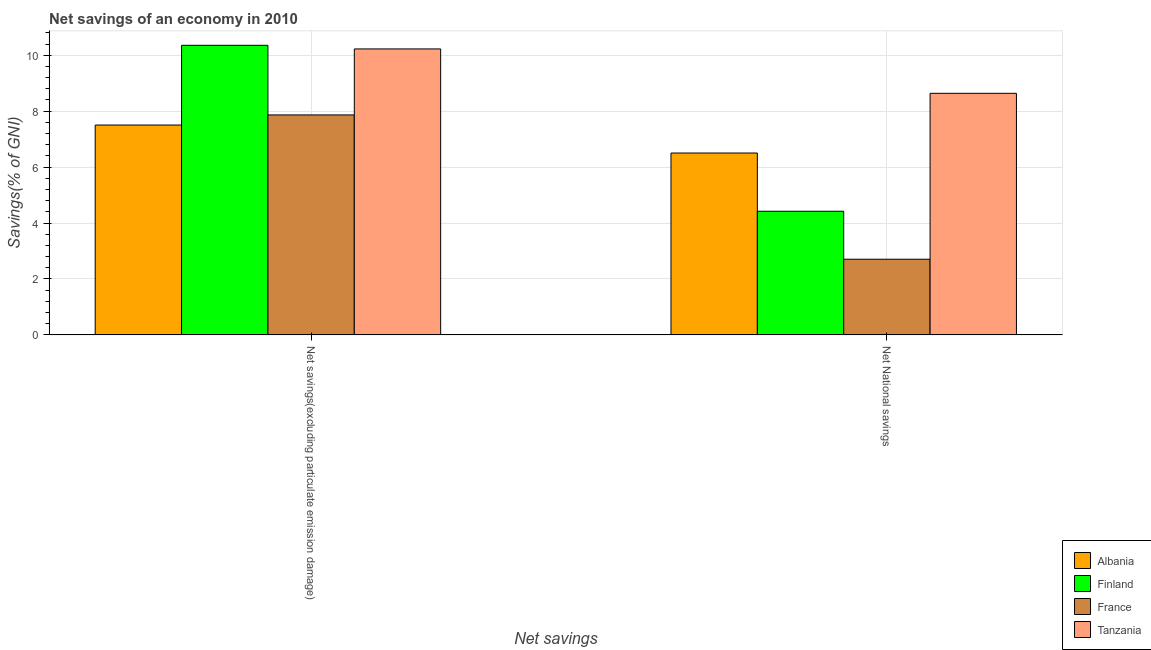How many different coloured bars are there?
Ensure brevity in your answer.  4. How many groups of bars are there?
Your answer should be compact. 2. How many bars are there on the 1st tick from the left?
Your answer should be very brief. 4. What is the label of the 2nd group of bars from the left?
Your answer should be compact. Net National savings. What is the net savings(excluding particulate emission damage) in Finland?
Give a very brief answer. 10.36. Across all countries, what is the maximum net savings(excluding particulate emission damage)?
Your response must be concise. 10.36. Across all countries, what is the minimum net savings(excluding particulate emission damage)?
Your answer should be compact. 7.5. In which country was the net national savings maximum?
Offer a terse response. Tanzania. In which country was the net national savings minimum?
Make the answer very short. France. What is the total net savings(excluding particulate emission damage) in the graph?
Give a very brief answer. 35.95. What is the difference between the net national savings in France and that in Finland?
Your response must be concise. -1.72. What is the difference between the net national savings in Finland and the net savings(excluding particulate emission damage) in Albania?
Give a very brief answer. -3.08. What is the average net national savings per country?
Make the answer very short. 5.57. What is the difference between the net savings(excluding particulate emission damage) and net national savings in Albania?
Provide a short and direct response. 1. What is the ratio of the net savings(excluding particulate emission damage) in Tanzania to that in France?
Offer a very short reply. 1.3. Is the net savings(excluding particulate emission damage) in Finland less than that in Albania?
Keep it short and to the point. No. Are all the bars in the graph horizontal?
Your response must be concise. No. Does the graph contain any zero values?
Provide a succinct answer. No. Does the graph contain grids?
Your answer should be very brief. Yes. How many legend labels are there?
Offer a terse response. 4. What is the title of the graph?
Your answer should be compact. Net savings of an economy in 2010. Does "Ghana" appear as one of the legend labels in the graph?
Ensure brevity in your answer.  No. What is the label or title of the X-axis?
Your answer should be compact. Net savings. What is the label or title of the Y-axis?
Give a very brief answer. Savings(% of GNI). What is the Savings(% of GNI) of Albania in Net savings(excluding particulate emission damage)?
Offer a very short reply. 7.5. What is the Savings(% of GNI) in Finland in Net savings(excluding particulate emission damage)?
Offer a very short reply. 10.36. What is the Savings(% of GNI) in France in Net savings(excluding particulate emission damage)?
Ensure brevity in your answer.  7.87. What is the Savings(% of GNI) of Tanzania in Net savings(excluding particulate emission damage)?
Your answer should be compact. 10.23. What is the Savings(% of GNI) in Albania in Net National savings?
Ensure brevity in your answer.  6.5. What is the Savings(% of GNI) in Finland in Net National savings?
Offer a very short reply. 4.42. What is the Savings(% of GNI) in France in Net National savings?
Offer a terse response. 2.71. What is the Savings(% of GNI) of Tanzania in Net National savings?
Ensure brevity in your answer.  8.64. Across all Net savings, what is the maximum Savings(% of GNI) of Albania?
Your answer should be compact. 7.5. Across all Net savings, what is the maximum Savings(% of GNI) in Finland?
Offer a very short reply. 10.36. Across all Net savings, what is the maximum Savings(% of GNI) of France?
Offer a very short reply. 7.87. Across all Net savings, what is the maximum Savings(% of GNI) in Tanzania?
Make the answer very short. 10.23. Across all Net savings, what is the minimum Savings(% of GNI) of Albania?
Provide a short and direct response. 6.5. Across all Net savings, what is the minimum Savings(% of GNI) in Finland?
Your answer should be very brief. 4.42. Across all Net savings, what is the minimum Savings(% of GNI) in France?
Offer a terse response. 2.71. Across all Net savings, what is the minimum Savings(% of GNI) in Tanzania?
Your response must be concise. 8.64. What is the total Savings(% of GNI) in Albania in the graph?
Your response must be concise. 14.01. What is the total Savings(% of GNI) of Finland in the graph?
Offer a very short reply. 14.78. What is the total Savings(% of GNI) of France in the graph?
Provide a short and direct response. 10.57. What is the total Savings(% of GNI) in Tanzania in the graph?
Give a very brief answer. 18.86. What is the difference between the Savings(% of GNI) of Finland in Net savings(excluding particulate emission damage) and that in Net National savings?
Provide a succinct answer. 5.93. What is the difference between the Savings(% of GNI) in France in Net savings(excluding particulate emission damage) and that in Net National savings?
Provide a short and direct response. 5.16. What is the difference between the Savings(% of GNI) in Tanzania in Net savings(excluding particulate emission damage) and that in Net National savings?
Give a very brief answer. 1.59. What is the difference between the Savings(% of GNI) of Albania in Net savings(excluding particulate emission damage) and the Savings(% of GNI) of Finland in Net National savings?
Your answer should be compact. 3.08. What is the difference between the Savings(% of GNI) in Albania in Net savings(excluding particulate emission damage) and the Savings(% of GNI) in France in Net National savings?
Offer a very short reply. 4.8. What is the difference between the Savings(% of GNI) of Albania in Net savings(excluding particulate emission damage) and the Savings(% of GNI) of Tanzania in Net National savings?
Keep it short and to the point. -1.13. What is the difference between the Savings(% of GNI) in Finland in Net savings(excluding particulate emission damage) and the Savings(% of GNI) in France in Net National savings?
Offer a very short reply. 7.65. What is the difference between the Savings(% of GNI) of Finland in Net savings(excluding particulate emission damage) and the Savings(% of GNI) of Tanzania in Net National savings?
Your response must be concise. 1.72. What is the difference between the Savings(% of GNI) in France in Net savings(excluding particulate emission damage) and the Savings(% of GNI) in Tanzania in Net National savings?
Offer a very short reply. -0.77. What is the average Savings(% of GNI) of Albania per Net savings?
Your answer should be very brief. 7. What is the average Savings(% of GNI) of Finland per Net savings?
Offer a very short reply. 7.39. What is the average Savings(% of GNI) of France per Net savings?
Keep it short and to the point. 5.29. What is the average Savings(% of GNI) in Tanzania per Net savings?
Make the answer very short. 9.43. What is the difference between the Savings(% of GNI) of Albania and Savings(% of GNI) of Finland in Net savings(excluding particulate emission damage)?
Keep it short and to the point. -2.85. What is the difference between the Savings(% of GNI) of Albania and Savings(% of GNI) of France in Net savings(excluding particulate emission damage)?
Your answer should be very brief. -0.36. What is the difference between the Savings(% of GNI) in Albania and Savings(% of GNI) in Tanzania in Net savings(excluding particulate emission damage)?
Keep it short and to the point. -2.72. What is the difference between the Savings(% of GNI) in Finland and Savings(% of GNI) in France in Net savings(excluding particulate emission damage)?
Give a very brief answer. 2.49. What is the difference between the Savings(% of GNI) of Finland and Savings(% of GNI) of Tanzania in Net savings(excluding particulate emission damage)?
Your answer should be compact. 0.13. What is the difference between the Savings(% of GNI) in France and Savings(% of GNI) in Tanzania in Net savings(excluding particulate emission damage)?
Offer a very short reply. -2.36. What is the difference between the Savings(% of GNI) in Albania and Savings(% of GNI) in Finland in Net National savings?
Your answer should be compact. 2.08. What is the difference between the Savings(% of GNI) of Albania and Savings(% of GNI) of France in Net National savings?
Provide a short and direct response. 3.8. What is the difference between the Savings(% of GNI) of Albania and Savings(% of GNI) of Tanzania in Net National savings?
Provide a succinct answer. -2.13. What is the difference between the Savings(% of GNI) in Finland and Savings(% of GNI) in France in Net National savings?
Offer a terse response. 1.72. What is the difference between the Savings(% of GNI) in Finland and Savings(% of GNI) in Tanzania in Net National savings?
Your answer should be very brief. -4.22. What is the difference between the Savings(% of GNI) of France and Savings(% of GNI) of Tanzania in Net National savings?
Provide a short and direct response. -5.93. What is the ratio of the Savings(% of GNI) of Albania in Net savings(excluding particulate emission damage) to that in Net National savings?
Provide a short and direct response. 1.15. What is the ratio of the Savings(% of GNI) in Finland in Net savings(excluding particulate emission damage) to that in Net National savings?
Keep it short and to the point. 2.34. What is the ratio of the Savings(% of GNI) of France in Net savings(excluding particulate emission damage) to that in Net National savings?
Your answer should be very brief. 2.91. What is the ratio of the Savings(% of GNI) of Tanzania in Net savings(excluding particulate emission damage) to that in Net National savings?
Offer a terse response. 1.18. What is the difference between the highest and the second highest Savings(% of GNI) of Albania?
Your answer should be very brief. 1. What is the difference between the highest and the second highest Savings(% of GNI) of Finland?
Provide a short and direct response. 5.93. What is the difference between the highest and the second highest Savings(% of GNI) in France?
Make the answer very short. 5.16. What is the difference between the highest and the second highest Savings(% of GNI) of Tanzania?
Your answer should be very brief. 1.59. What is the difference between the highest and the lowest Savings(% of GNI) in Finland?
Make the answer very short. 5.93. What is the difference between the highest and the lowest Savings(% of GNI) of France?
Provide a succinct answer. 5.16. What is the difference between the highest and the lowest Savings(% of GNI) of Tanzania?
Provide a succinct answer. 1.59. 